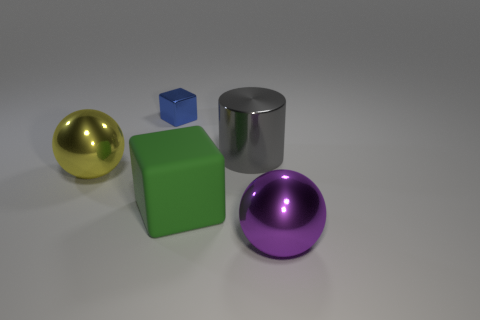There is a gray shiny thing that is to the right of the small blue thing; does it have the same shape as the shiny object behind the big gray metal object?
Your answer should be compact. No. Are there any gray things made of the same material as the big gray cylinder?
Your response must be concise. No. The block behind the metallic sphere behind the purple ball in front of the metal cylinder is what color?
Your answer should be very brief. Blue. Is the large sphere on the right side of the tiny blue object made of the same material as the cube that is left of the big green matte cube?
Provide a succinct answer. Yes. There is a big gray metal object that is behind the rubber block; what shape is it?
Provide a short and direct response. Cylinder. What number of things are large yellow metallic blocks or things on the left side of the purple metallic sphere?
Offer a terse response. 4. Do the purple object and the large green thing have the same material?
Ensure brevity in your answer.  No. Is the number of metal balls in front of the yellow shiny sphere the same as the number of small blocks in front of the large green block?
Your answer should be compact. No. There is a green rubber cube; what number of spheres are right of it?
Keep it short and to the point. 1. How many objects are either large brown cylinders or large yellow metallic spheres?
Ensure brevity in your answer.  1. 